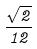Convert formula to latex. <formula><loc_0><loc_0><loc_500><loc_500>\frac { \sqrt { 2 } } { 1 2 }</formula> 